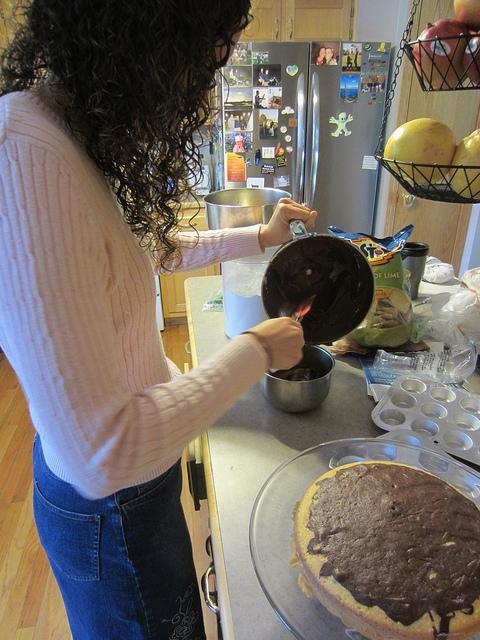How was the item on the plate cooked? baked 